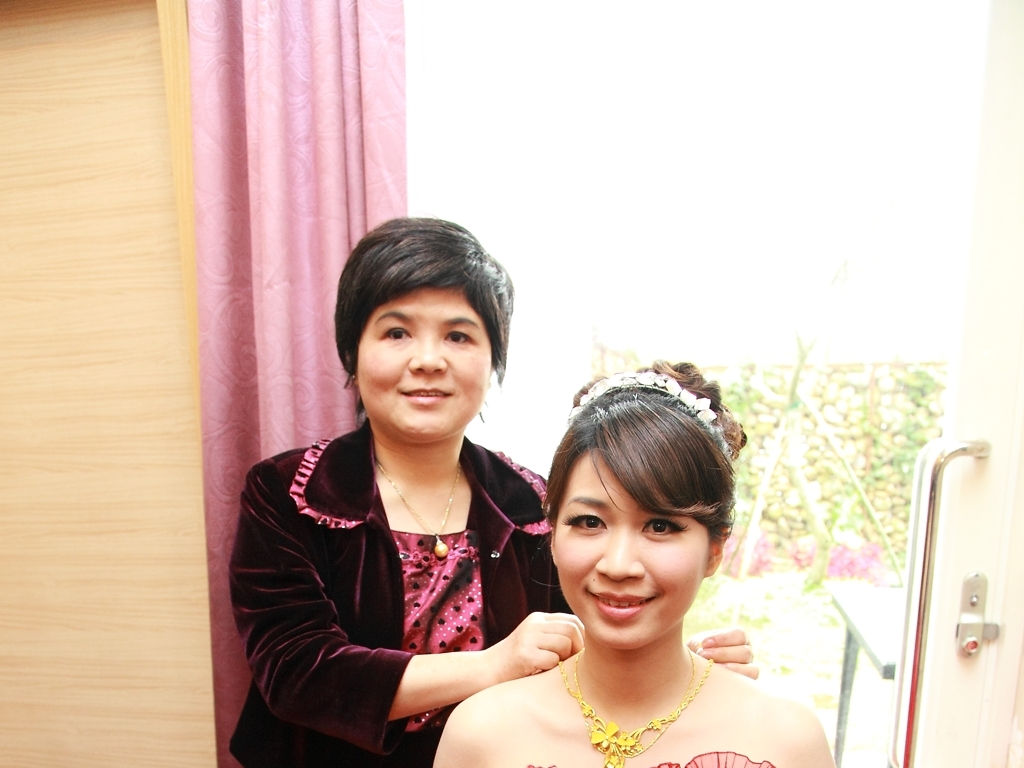Can you describe the setting and what the people are doing in this image? The image depicts an indoor setting with two people. It appears to be a special occasion, possibly a preparation for an event like a wedding, as indicated by the woman on the right wearing an elegant dress and a hair ornament. The woman on the left appears to be helping the woman on the right with her attire. 